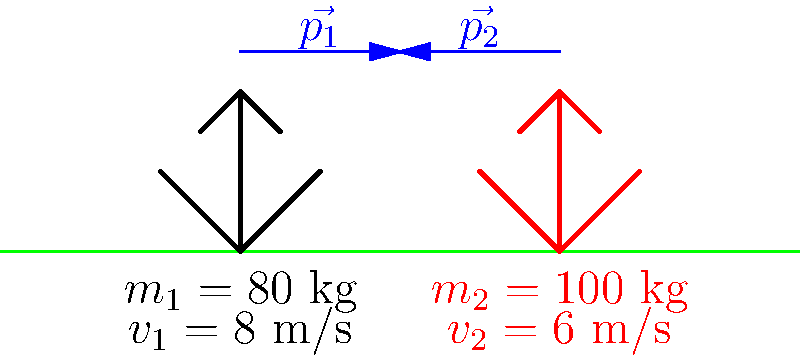In a crucial play, two football players are about to collide head-on. Player 1 (black) has a mass of 80 kg and is running at 8 m/s, while Player 2 (red) has a mass of 100 kg and is running at 6 m/s in the opposite direction. Assuming a perfectly inelastic collision (they stick together after the tackle), what will be their combined velocity immediately after impact? Let's approach this step-by-step using the principle of conservation of momentum:

1) First, let's define our coordinate system. We'll consider the direction of Player 1's motion as positive.

2) Calculate the initial momentum of each player:
   Player 1: $p_1 = m_1v_1 = (80 \text{ kg})(8 \text{ m/s}) = 640 \text{ kg}\cdot\text{m/s}$
   Player 2: $p_2 = m_2v_2 = (100 \text{ kg})(-6 \text{ m/s}) = -600 \text{ kg}\cdot\text{m/s}$

3) The total initial momentum is:
   $p_{\text{total}} = p_1 + p_2 = 640 - 600 = 40 \text{ kg}\cdot\text{m/s}$

4) In an inelastic collision, momentum is conserved. So, the final momentum will equal the initial momentum:
   $p_{\text{final}} = p_{\text{total}} = 40 \text{ kg}\cdot\text{m/s}$

5) After the collision, the players move together with a combined mass of:
   $m_{\text{total}} = m_1 + m_2 = 80 \text{ kg} + 100 \text{ kg} = 180 \text{ kg}$

6) We can find the final velocity using the relationship $p = mv$:
   $v_{\text{final}} = \frac{p_{\text{final}}}{m_{\text{total}}} = \frac{40 \text{ kg}\cdot\text{m/s}}{180 \text{ kg}} = \frac{2}{9} \text{ m/s} \approx 0.22 \text{ m/s}$

Therefore, immediately after impact, the players will move together in the direction of Player 1 at approximately 0.22 m/s.
Answer: 0.22 m/s in Player 1's direction 